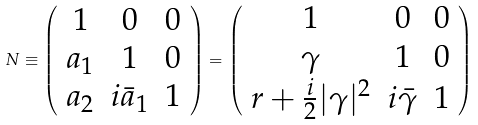<formula> <loc_0><loc_0><loc_500><loc_500>N \equiv \left ( \begin{array} { c c c } 1 & 0 & 0 \\ a _ { 1 } & 1 & 0 \\ a _ { 2 } & i \bar { a } _ { 1 } & 1 \end{array} \right ) = \left ( \begin{array} { c c c } 1 & 0 & 0 \\ \gamma & 1 & 0 \\ r + \frac { i } { 2 } | \gamma | ^ { 2 } & i \bar { \gamma } & 1 \end{array} \right )</formula> 